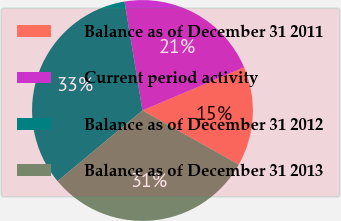Convert chart to OTSL. <chart><loc_0><loc_0><loc_500><loc_500><pie_chart><fcel>Balance as of December 31 2011<fcel>Current period activity<fcel>Balance as of December 31 2012<fcel>Balance as of December 31 2013<nl><fcel>14.54%<fcel>21.2%<fcel>33.45%<fcel>30.81%<nl></chart> 